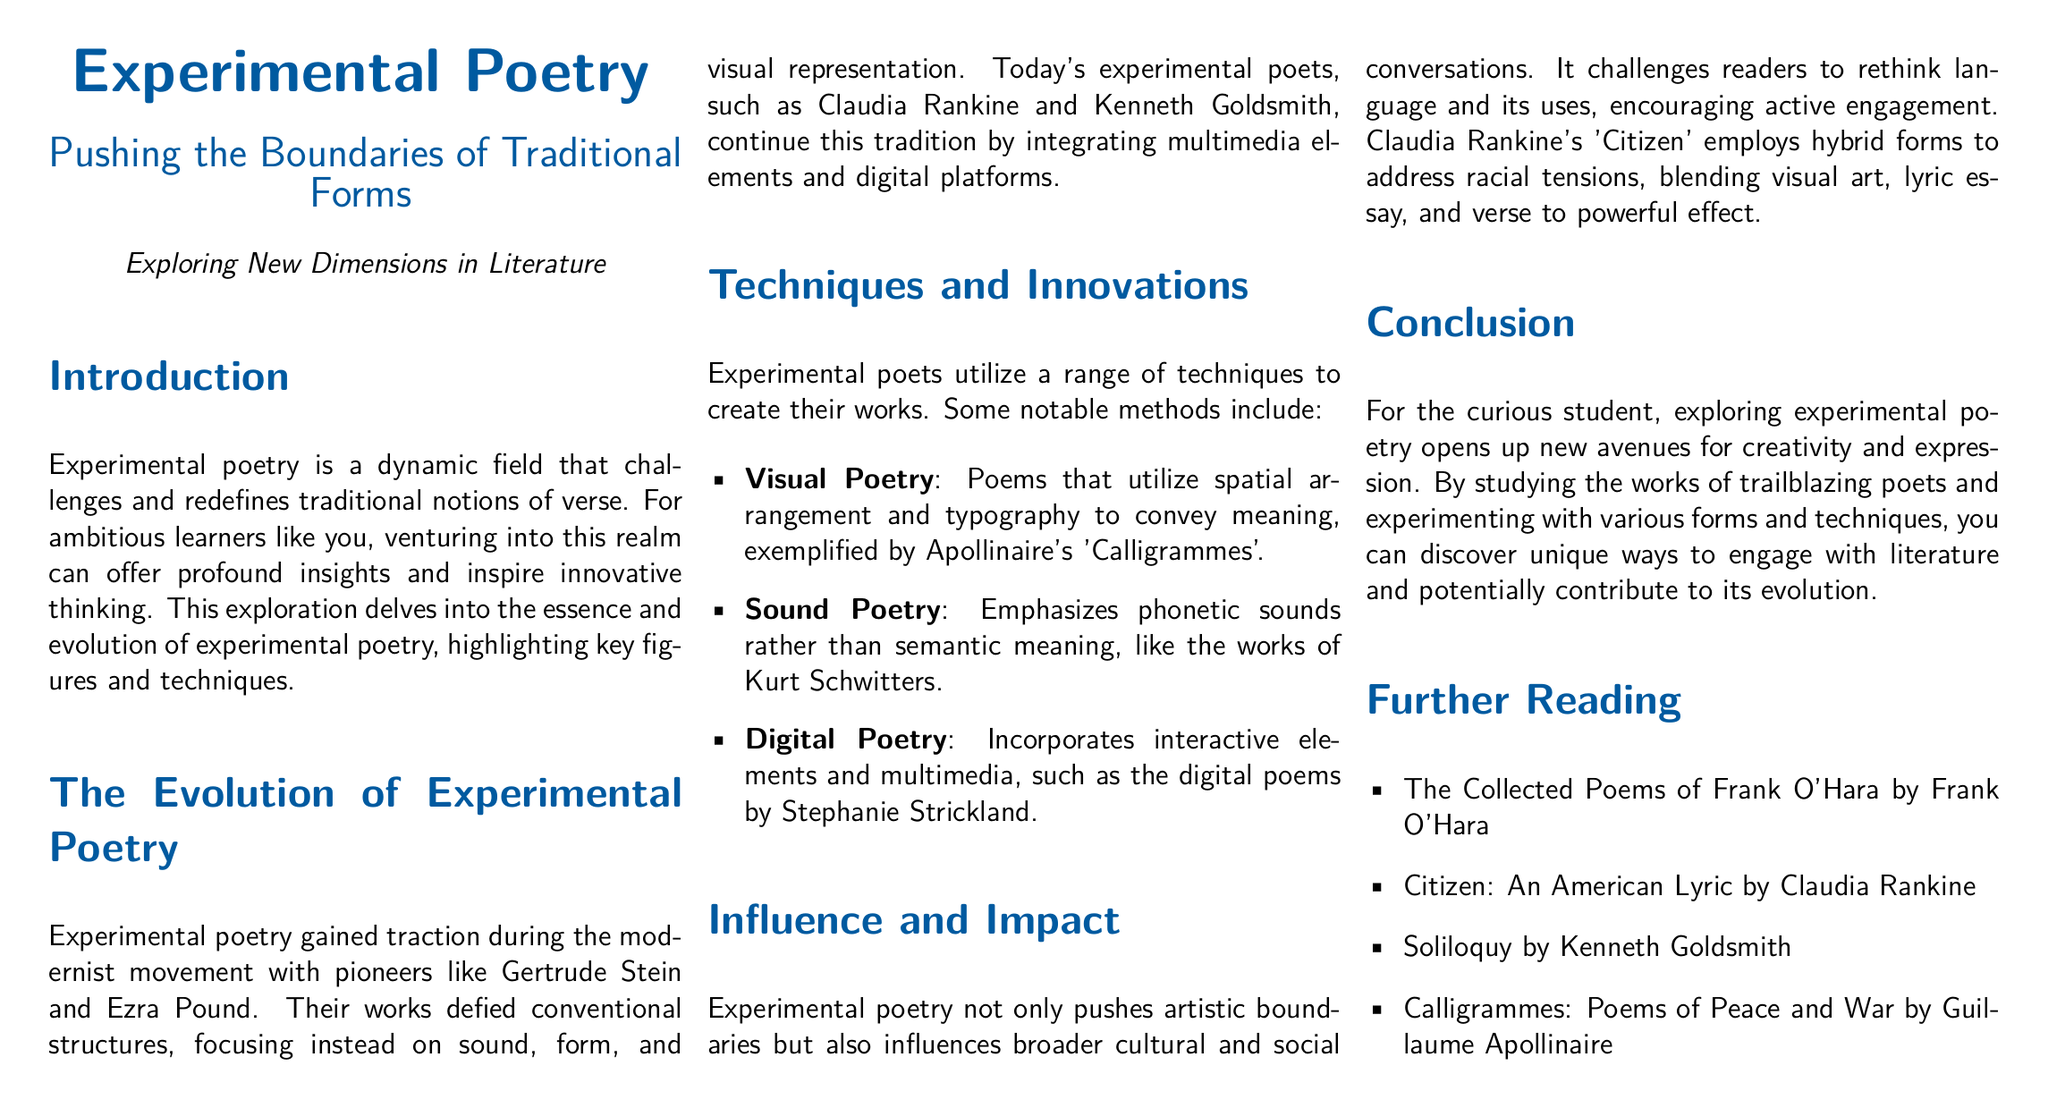What is the main focus of experimental poetry? The introduction states that experimental poetry challenges and redefines traditional notions of verse.
Answer: Traditional notions of verse Who are the pioneers of experimental poetry mentioned in the document? The document mentions Gertrude Stein and Ezra Pound as pioneers of experimental poetry.
Answer: Gertrude Stein and Ezra Pound What notable method is exemplified by Apollinaire's 'Calligrammes'? The document states that visual poetry utilizes spatial arrangement and typography to convey meaning, exemplified by Apollinaire's work.
Answer: Visual Poetry Which contemporary poet is mentioned for integrating multimedia elements? Claudia Rankine is highlighted for her integration of multimedia elements in experimental poetry.
Answer: Claudia Rankine What transformative impact does experimental poetry have on readers? The document explains that experimental poetry challenges readers to rethink language and encourages active engagement.
Answer: Rethink language Name one book listed under further reading. One of the further reading titles is 'Citizen: An American Lyric' by Claudia Rankine.
Answer: Citizen: An American Lyric What type of poetry emphasizes phonetic sounds? Sound poetry emphasizes phonetic sounds over semantic meaning, as noted in the document.
Answer: Sound Poetry How does Claudia Rankine's 'Citizen' blend different forms? The document mentions that 'Citizen' blends visual art, lyric essay, and verse.
Answer: Visual art, lyric essay, and verse What is the printing format of the document? The document is designed in a landscape format using the A4 paper size.
Answer: Landscape format 